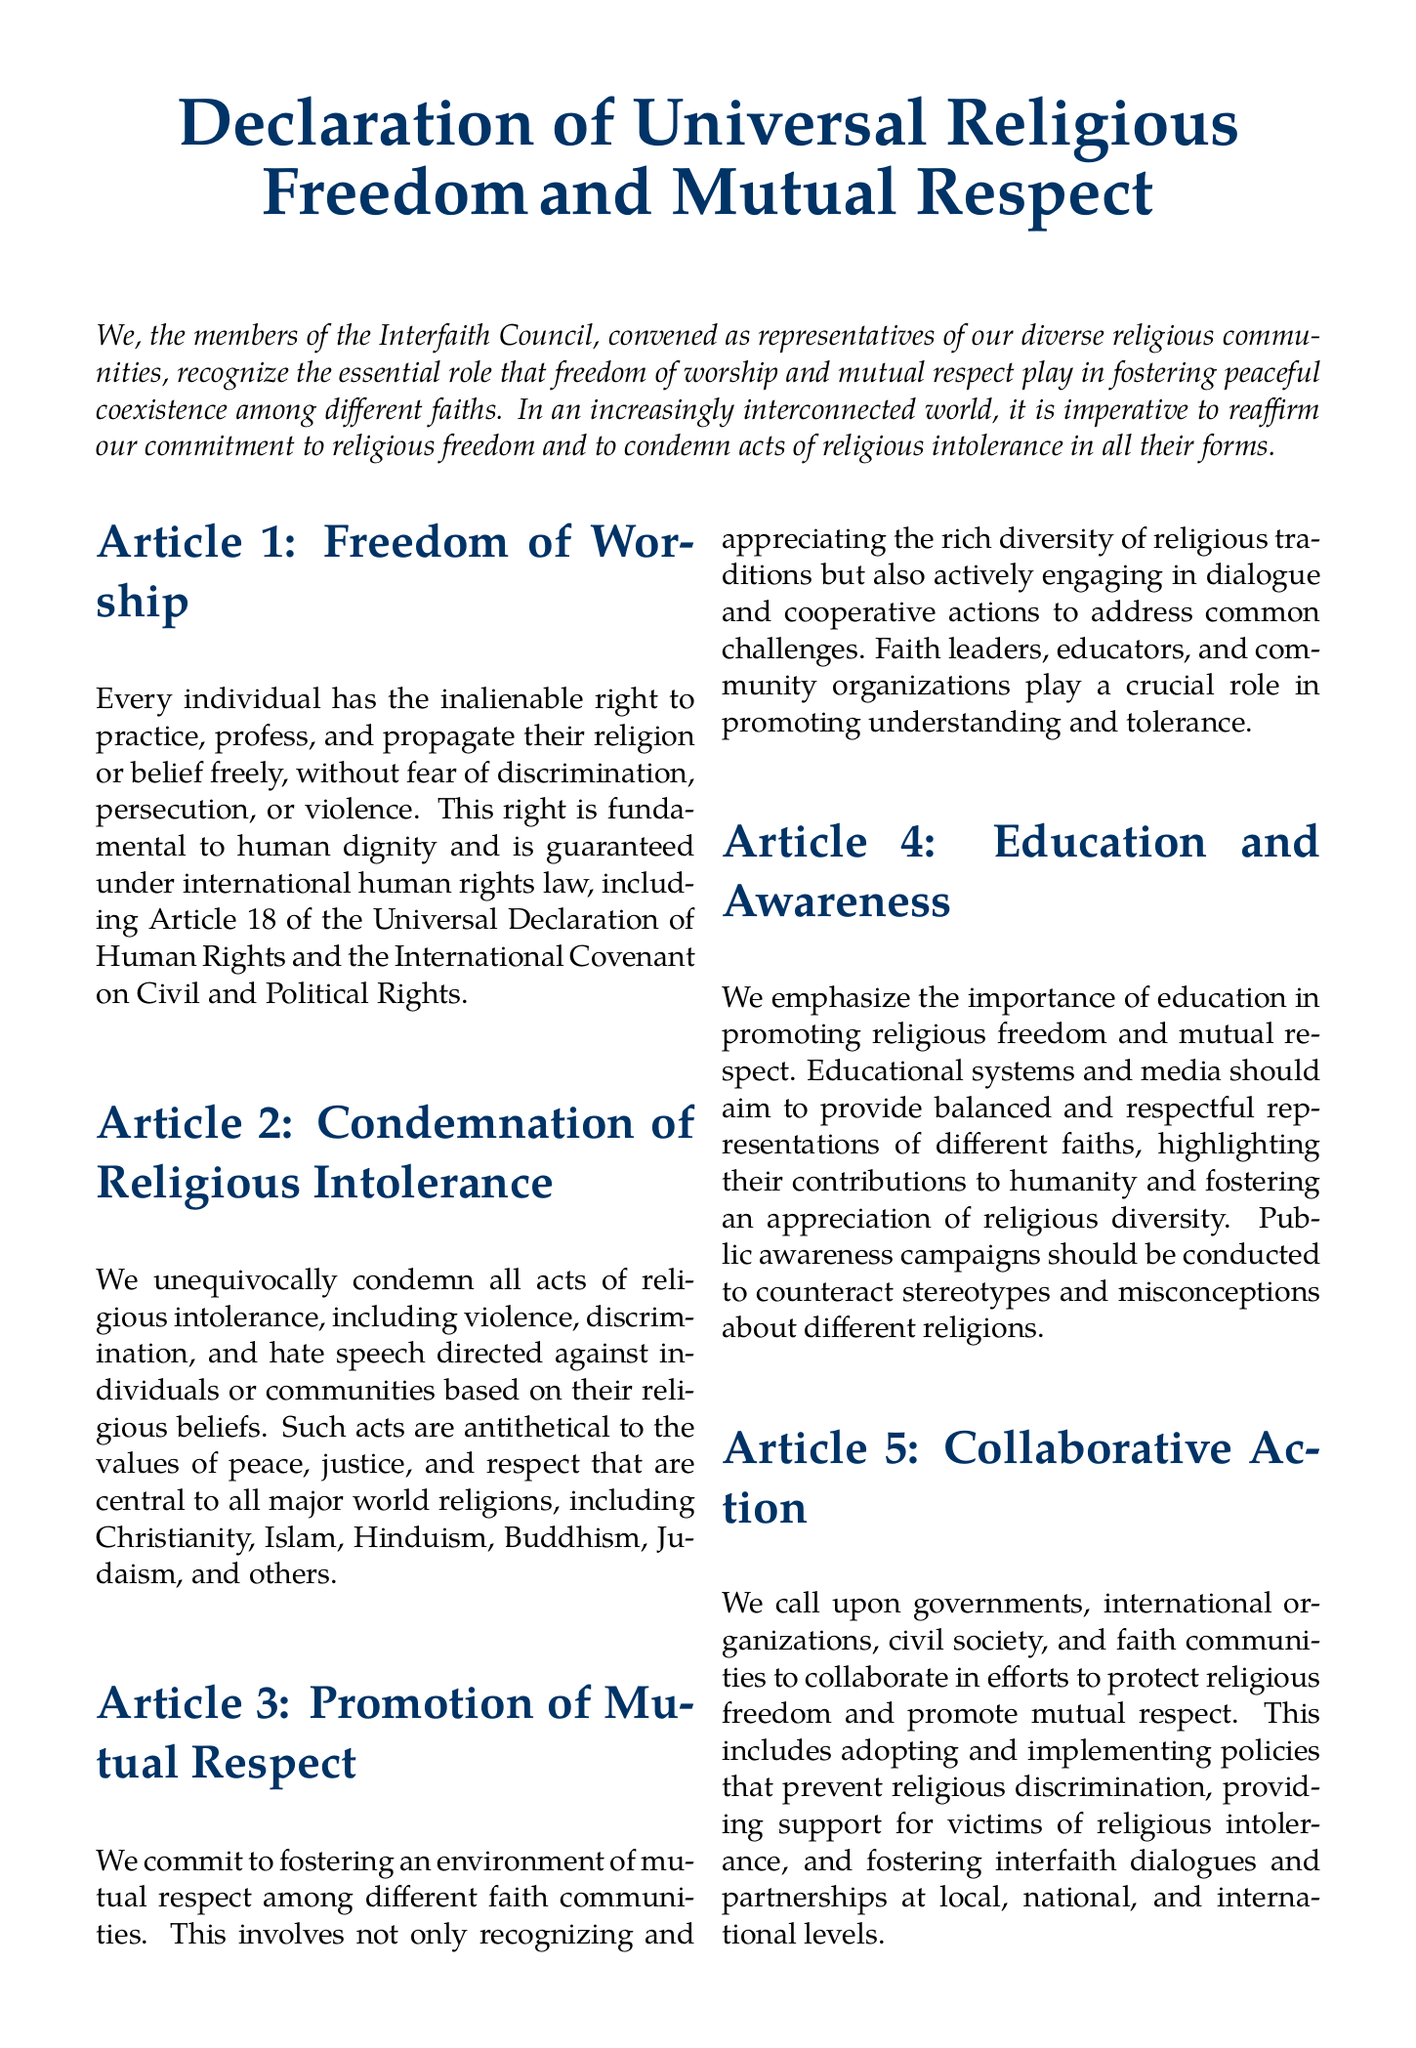What is the title of the declaration? The title of the declaration is found at the top of the document in a large font, emphasizing its importance.
Answer: Declaration of Universal Religious Freedom and Mutual Respect Who signed the declaration? The declaration is signed by the leader of the Interfaith Council, which is mentioned at the bottom of the document.
Answer: President of the Interfaith Council What is the date of signing? The date appears beneath the signature line, marking when the declaration was formalized.
Answer: Today's date What article discusses the right to practice religion? The article number relating to the right to practice religion provides a specific focus on freedom of worship.
Answer: Article 1 How many articles are there in the declaration? The total number of sections that outline the principles and commitments made in the declaration can be counted in the document.
Answer: Five What does Article 2 condemn? This article explicitly addresses negative actions towards individuals or communities and outlines what is not acceptable.
Answer: Religious intolerance What is emphasized in Article 4? This article focuses on a particular aspect crucial to achieving the goals set forth in the declaration and specifies a means to promote them.
Answer: Education and Awareness Which communities are encouraged to collaborate in Article 5? This article calls for action among various groups to foster the goals outlined in the declaration.
Answer: Governments, international organizations, civil society, and faith communities What is the main vision expressed at the end of the declaration? The conclusion restates the overall goal that all signatories aspire to achieve concerning individuals and their beliefs.
Answer: Peace, with respect for their religious beliefs 